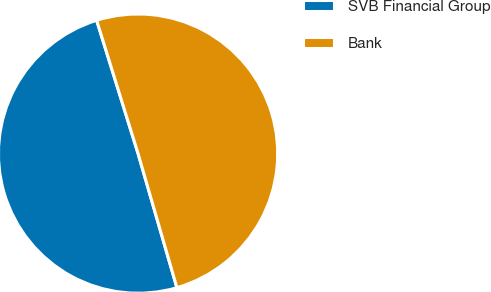Convert chart to OTSL. <chart><loc_0><loc_0><loc_500><loc_500><pie_chart><fcel>SVB Financial Group<fcel>Bank<nl><fcel>49.69%<fcel>50.31%<nl></chart> 